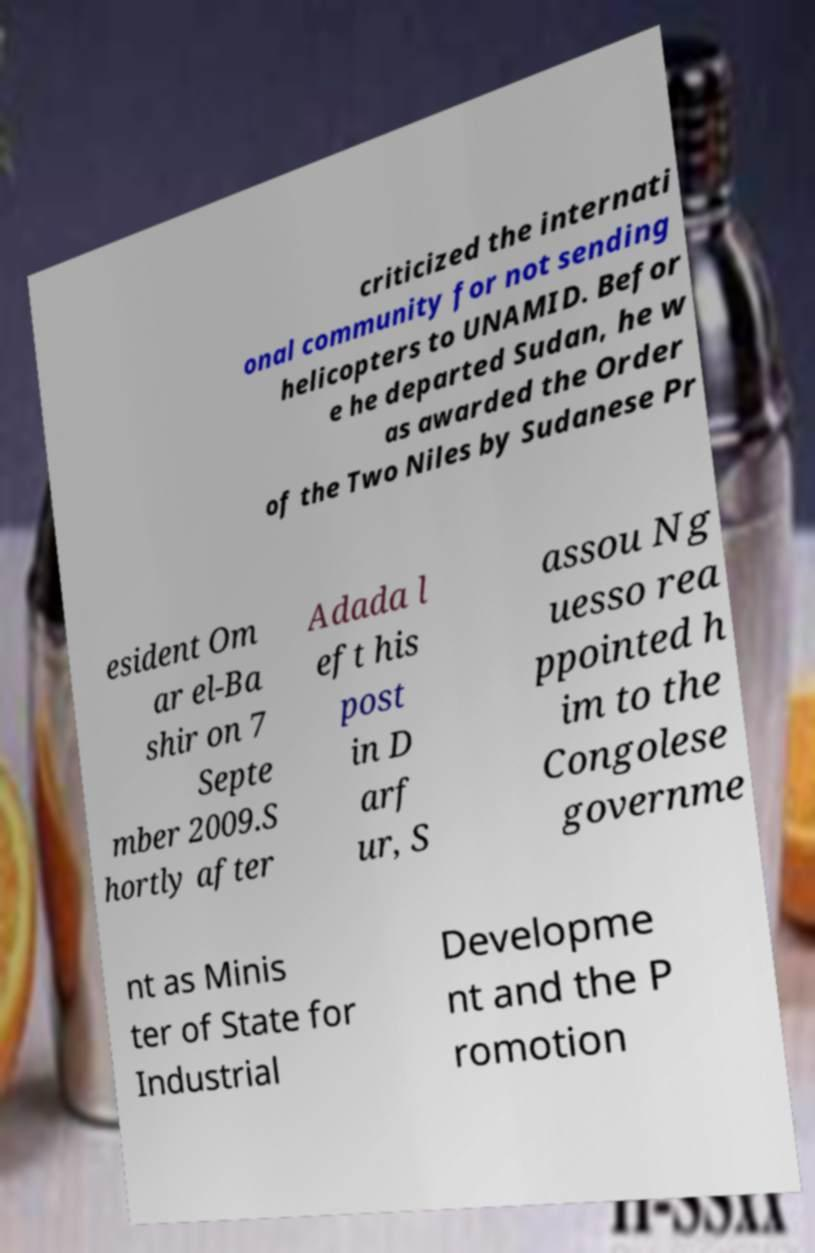I need the written content from this picture converted into text. Can you do that? criticized the internati onal community for not sending helicopters to UNAMID. Befor e he departed Sudan, he w as awarded the Order of the Two Niles by Sudanese Pr esident Om ar el-Ba shir on 7 Septe mber 2009.S hortly after Adada l eft his post in D arf ur, S assou Ng uesso rea ppointed h im to the Congolese governme nt as Minis ter of State for Industrial Developme nt and the P romotion 